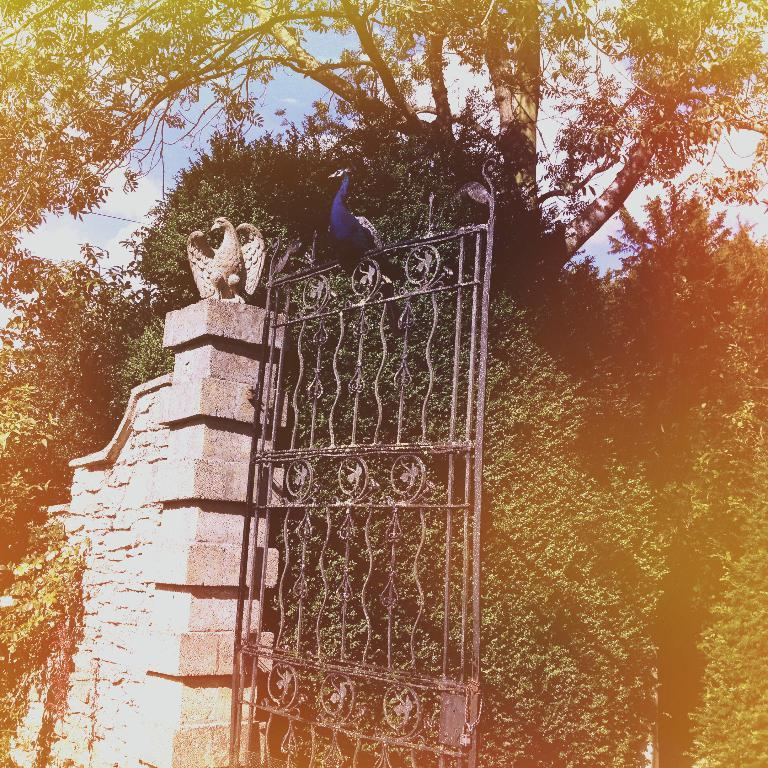What is on the gate in the image? There is a bird on the gate in the image. What can be seen on the wall in the image? There is a sculpture on the wall in the image. What type of vegetation is visible in the background of the image? There are trees in the background of the image. What is visible in the sky in the image? The sky is visible in the background of the image. Where is the laborer working in the image? There is no laborer present in the image. What type of farm can be seen in the background of the image? There is no farm present in the image; it features a bird on a gate, a sculpture on a wall, trees, and the sky. 